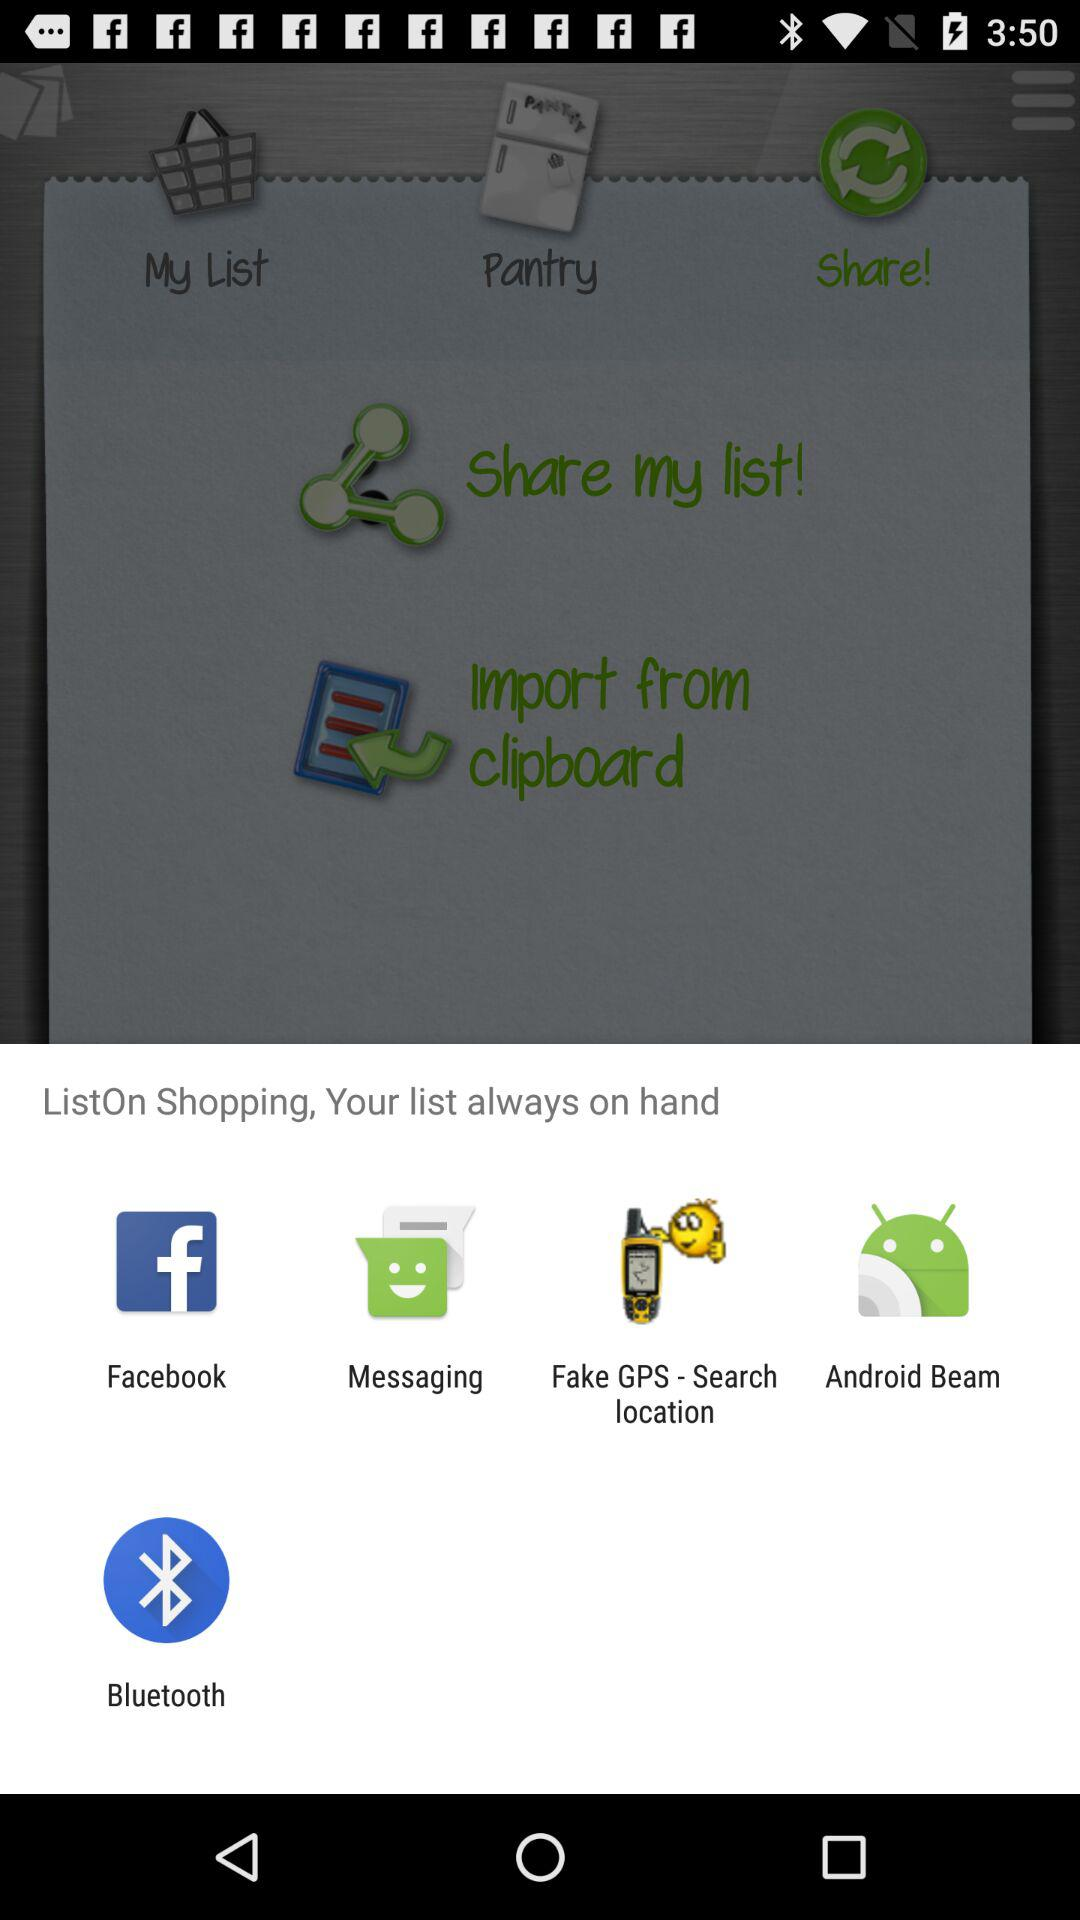Which application can be used for sharing the "ListOn" shopping application? The applications "Facebook", "Messaging", "Fake GPS - Search location", "Android Beam" and "Bluetooth" can be used for sharing. 